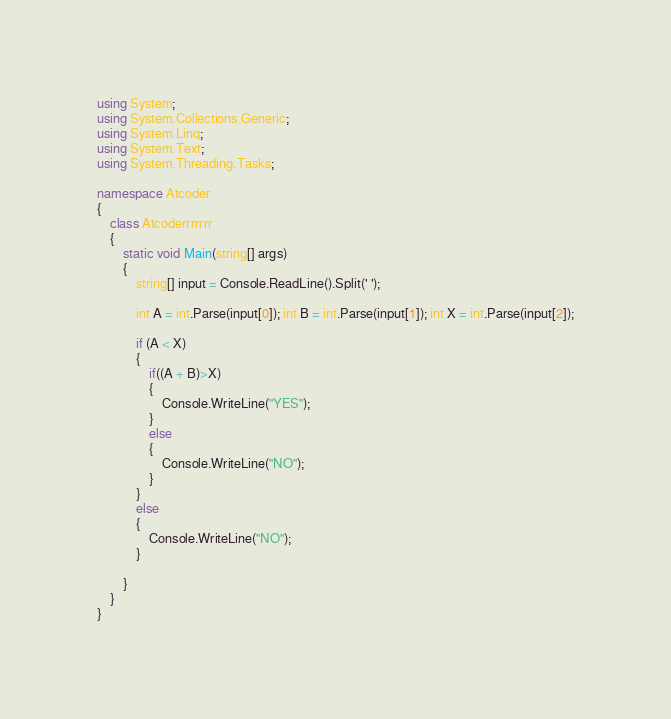<code> <loc_0><loc_0><loc_500><loc_500><_C#_>using System;
using System.Collections.Generic;
using System.Linq;
using System.Text;
using System.Threading.Tasks;

namespace Atcoder
{
    class Atcoderrrrrrr
    {
        static void Main(string[] args)
        {
            string[] input = Console.ReadLine().Split(' ');

            int A = int.Parse(input[0]); int B = int.Parse(input[1]); int X = int.Parse(input[2]);

            if (A < X)
            {
                if((A + B)>X)
                {
                    Console.WriteLine("YES");
                }
                else
                {
                    Console.WriteLine("NO");
                }
            }
            else
            {
                Console.WriteLine("NO");
            }

        }
    }
}
</code> 